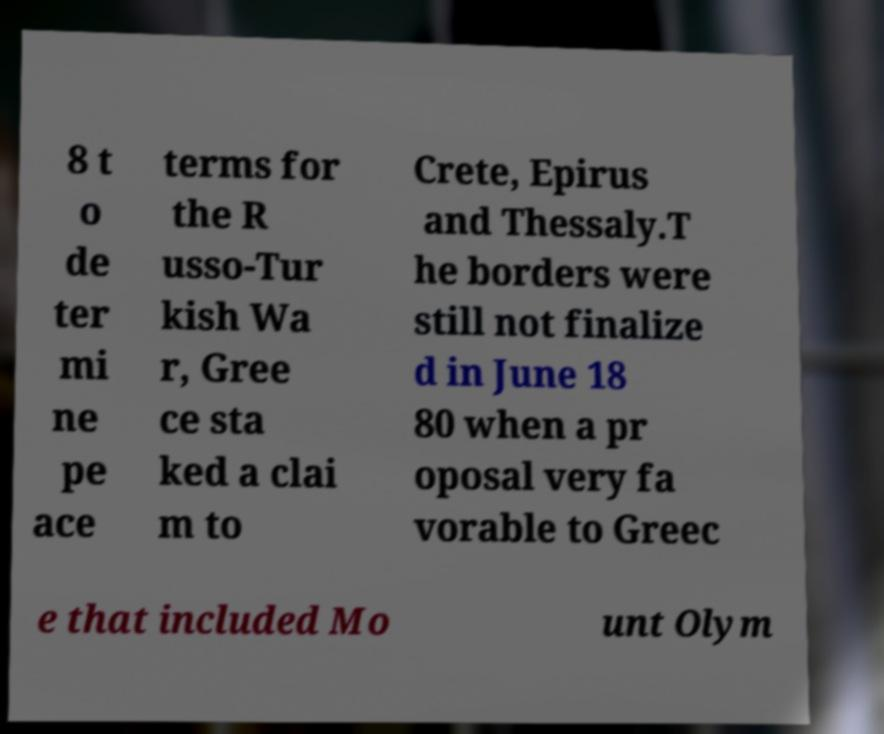Please read and relay the text visible in this image. What does it say? 8 t o de ter mi ne pe ace terms for the R usso-Tur kish Wa r, Gree ce sta ked a clai m to Crete, Epirus and Thessaly.T he borders were still not finalize d in June 18 80 when a pr oposal very fa vorable to Greec e that included Mo unt Olym 